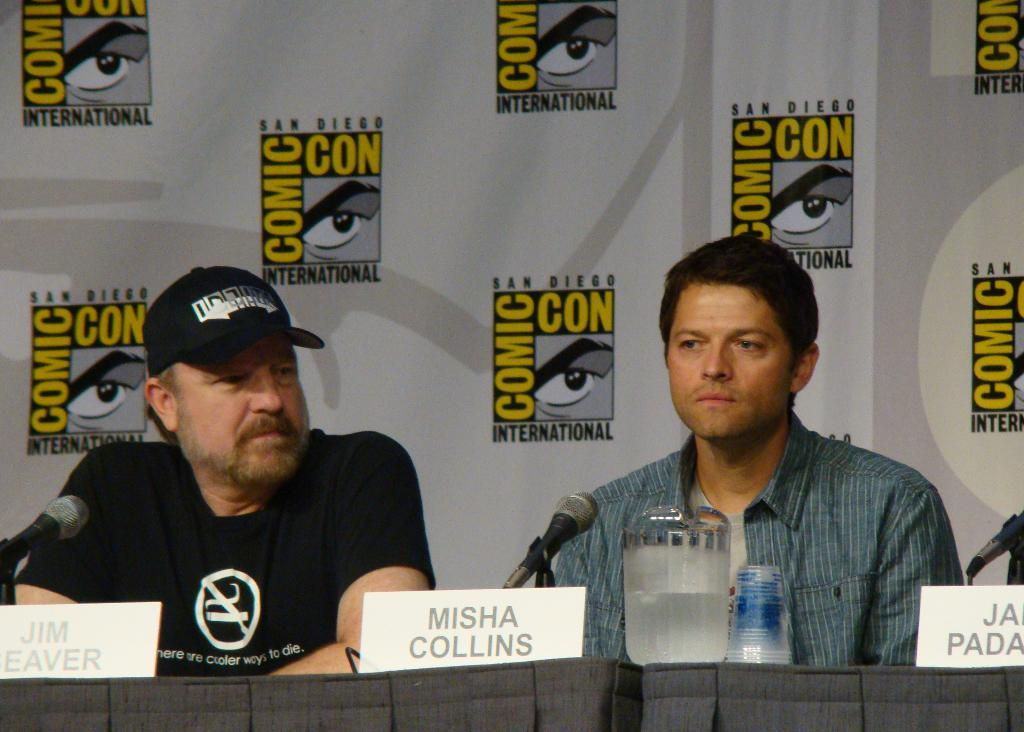Provide a one-sentence caption for the provided image. a couple men talking with one having a Misha Collins sign in front of them. 